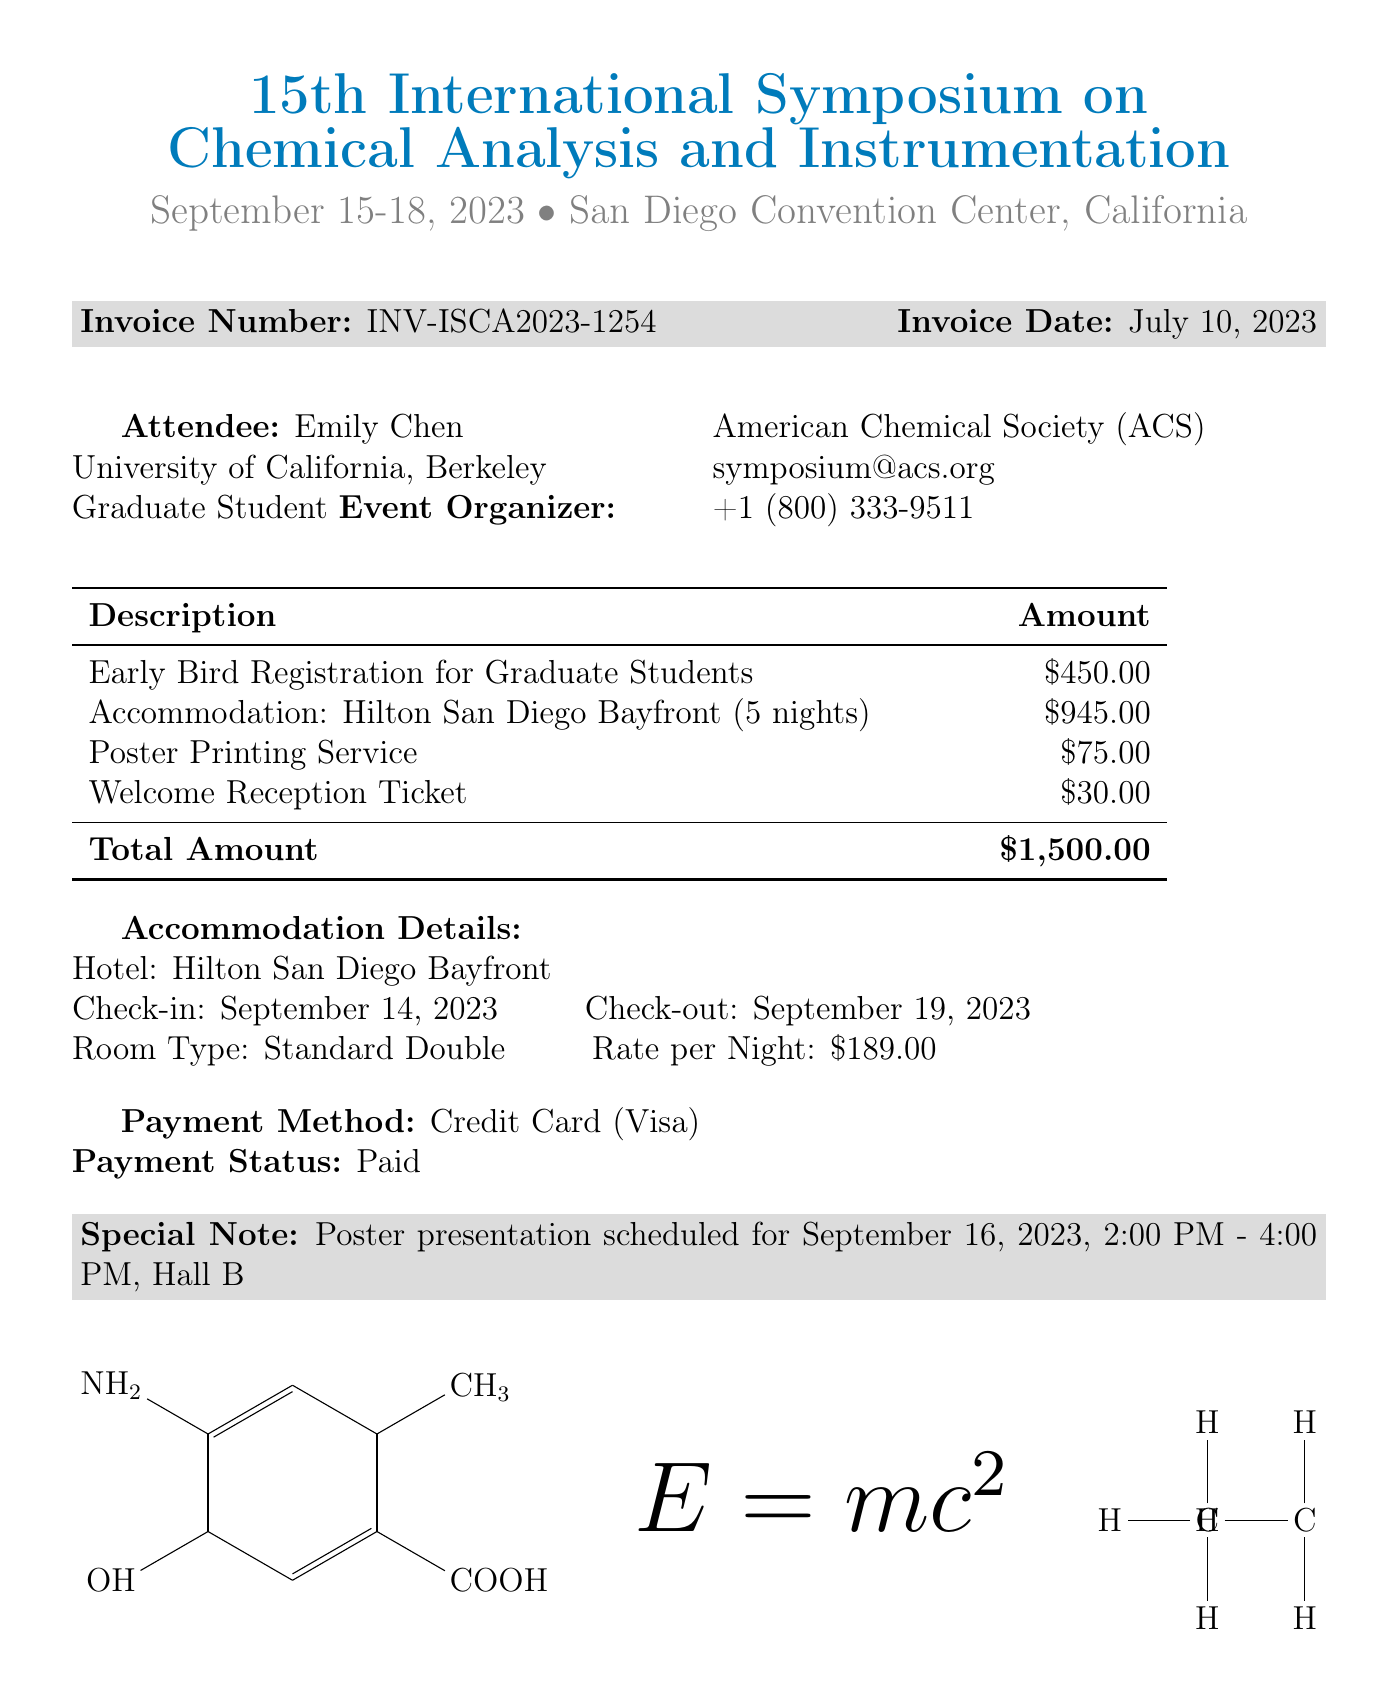What is the event name? The event name is clearly stated at the top of the document.
Answer: 15th International Symposium on Chemical Analysis and Instrumentation What is the invoice number? The invoice number is mentioned in the designated section of the document.
Answer: INV-ISCA2023-1254 What is the total accommodation cost? The total accommodation cost is specified along with the breakdown of the lodging details.
Answer: 945.00 Who organized the event? The organizer of the event is listed in the attendee section.
Answer: American Chemical Society (ACS) How many nights is the accommodation for? The number of nights for accommodation is provided in the accommodation details.
Answer: 5 What date is the poster presentation scheduled for? The date for the poster presentation is noted in the special notes section.
Answer: September 16, 2023 What was the registration fee for graduate students? The registration fee is detailed in the table of costs.
Answer: 450.00 What payment method was used? The payment method is stated in the payment details section of the invoice.
Answer: Credit Card (Visa) What is the check-out date from the hotel? The check-out date is listed in the accommodation details.
Answer: September 19, 2023 